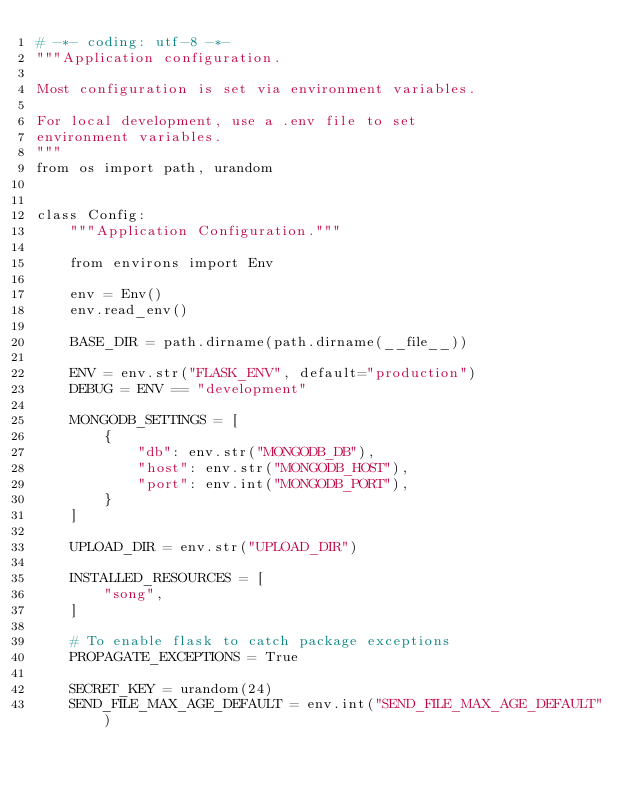Convert code to text. <code><loc_0><loc_0><loc_500><loc_500><_Python_># -*- coding: utf-8 -*-
"""Application configuration.

Most configuration is set via environment variables.

For local development, use a .env file to set
environment variables.
"""
from os import path, urandom


class Config:
    """Application Configuration."""

    from environs import Env

    env = Env()
    env.read_env()

    BASE_DIR = path.dirname(path.dirname(__file__))

    ENV = env.str("FLASK_ENV", default="production")
    DEBUG = ENV == "development"

    MONGODB_SETTINGS = [
        {
            "db": env.str("MONGODB_DB"),
            "host": env.str("MONGODB_HOST"),
            "port": env.int("MONGODB_PORT"),
        }
    ]

    UPLOAD_DIR = env.str("UPLOAD_DIR")

    INSTALLED_RESOURCES = [
        "song",
    ]

    # To enable flask to catch package exceptions
    PROPAGATE_EXCEPTIONS = True

    SECRET_KEY = urandom(24)
    SEND_FILE_MAX_AGE_DEFAULT = env.int("SEND_FILE_MAX_AGE_DEFAULT")
</code> 